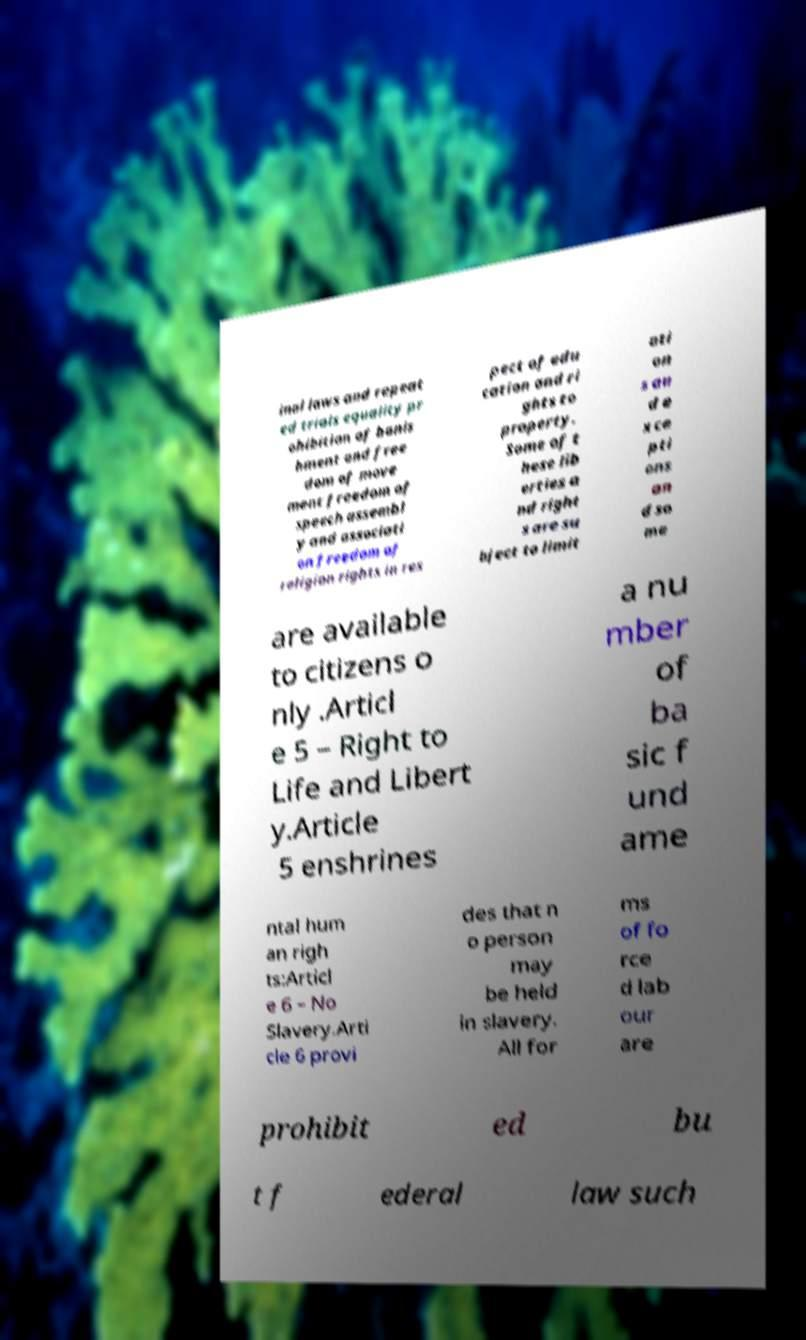What messages or text are displayed in this image? I need them in a readable, typed format. inal laws and repeat ed trials equality pr ohibition of banis hment and free dom of move ment freedom of speech assembl y and associati on freedom of religion rights in res pect of edu cation and ri ghts to property. Some of t hese lib erties a nd right s are su bject to limit ati on s an d e xce pti ons an d so me are available to citizens o nly .Articl e 5 – Right to Life and Libert y.Article 5 enshrines a nu mber of ba sic f und ame ntal hum an righ ts:Articl e 6 – No Slavery.Arti cle 6 provi des that n o person may be held in slavery. All for ms of fo rce d lab our are prohibit ed bu t f ederal law such 